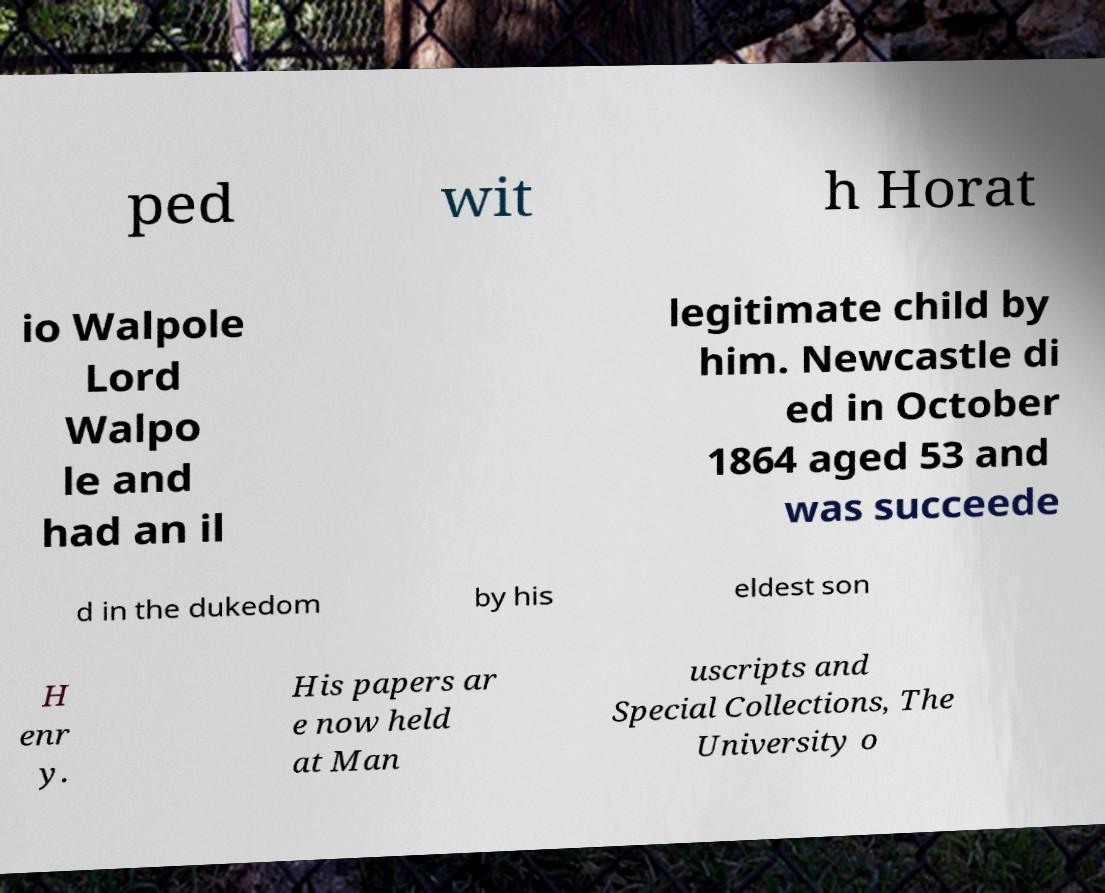Please identify and transcribe the text found in this image. ped wit h Horat io Walpole Lord Walpo le and had an il legitimate child by him. Newcastle di ed in October 1864 aged 53 and was succeede d in the dukedom by his eldest son H enr y. His papers ar e now held at Man uscripts and Special Collections, The University o 